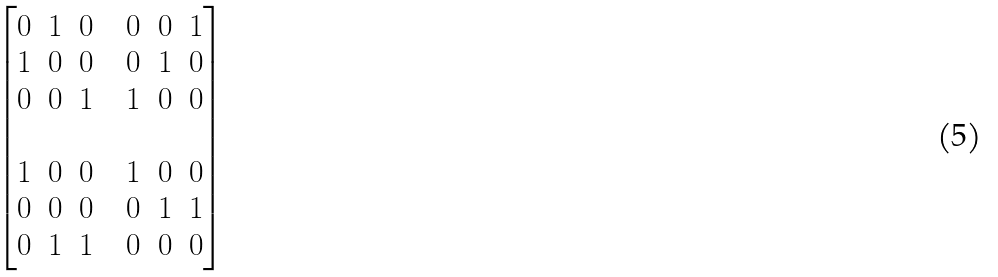Convert formula to latex. <formula><loc_0><loc_0><loc_500><loc_500>\begin{bmatrix} \begin{matrix} 0 & 1 & 0 \\ 1 & 0 & 0 \\ 0 & 0 & 1 \end{matrix} & & \begin{matrix} 0 & 0 & 1 \\ 0 & 1 & 0 \\ 1 & 0 & 0 \end{matrix} \\ \\ \begin{matrix} 1 & 0 & 0 \\ 0 & 0 & 0 \\ 0 & 1 & 1 \end{matrix} & & \begin{matrix} 1 & 0 & 0 \\ 0 & 1 & 1 \\ 0 & 0 & 0 \end{matrix} \end{bmatrix}</formula> 